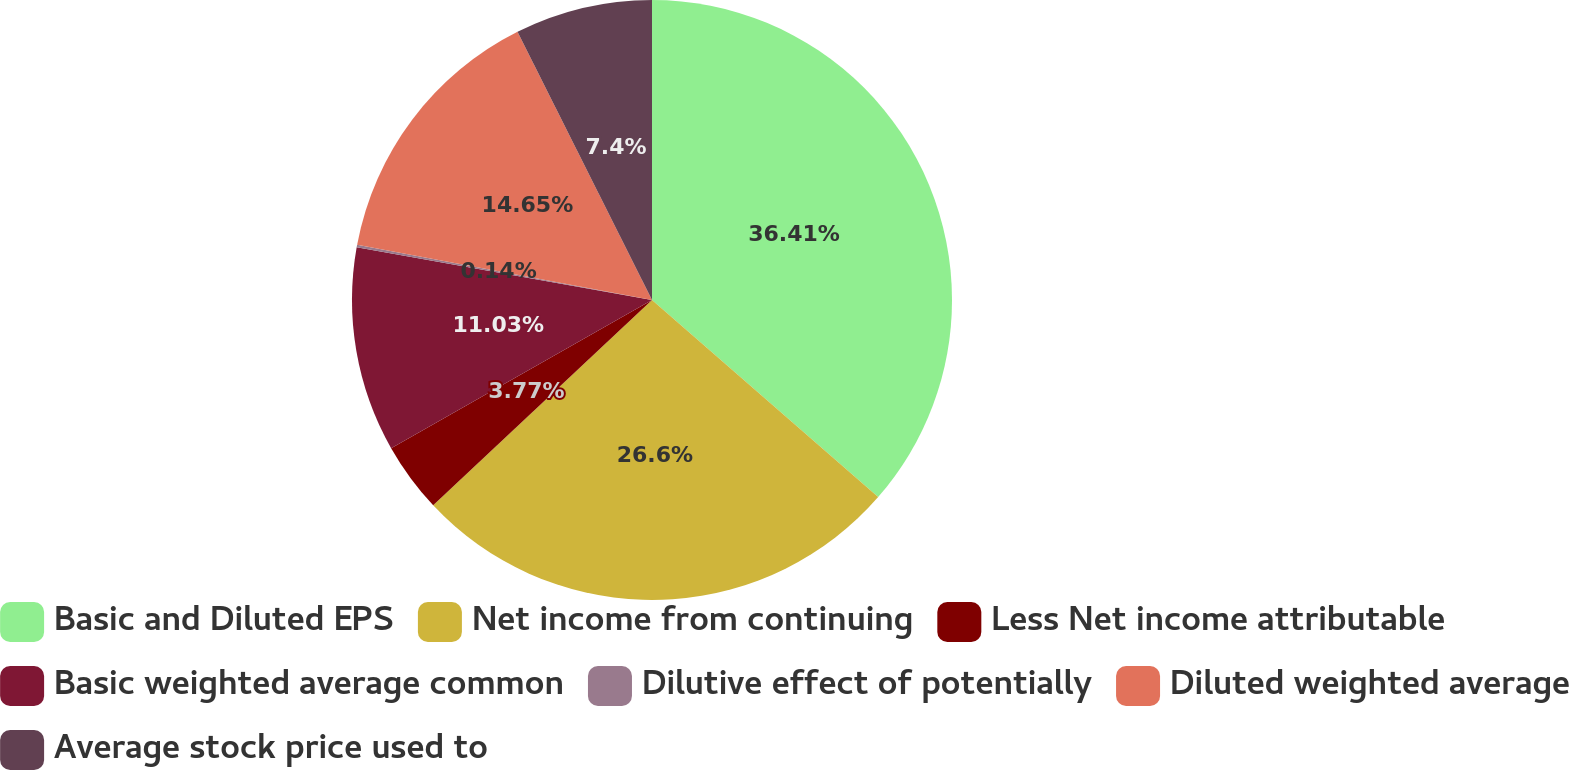Convert chart. <chart><loc_0><loc_0><loc_500><loc_500><pie_chart><fcel>Basic and Diluted EPS<fcel>Net income from continuing<fcel>Less Net income attributable<fcel>Basic weighted average common<fcel>Dilutive effect of potentially<fcel>Diluted weighted average<fcel>Average stock price used to<nl><fcel>36.41%<fcel>26.6%<fcel>3.77%<fcel>11.03%<fcel>0.14%<fcel>14.65%<fcel>7.4%<nl></chart> 